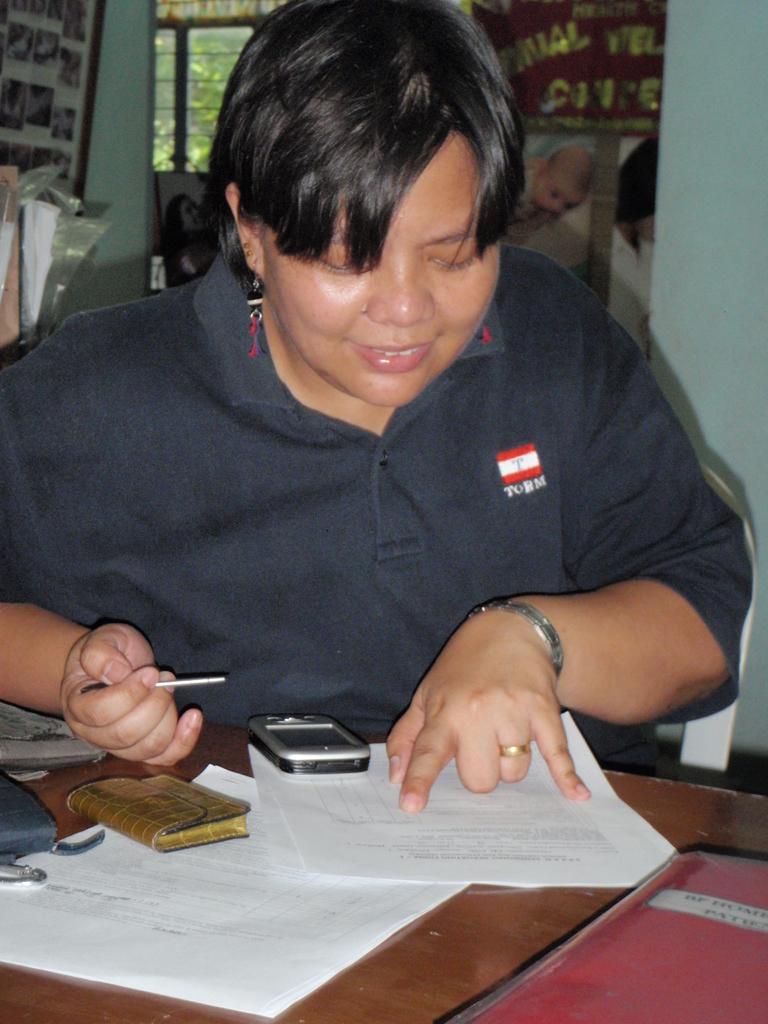Describe this image in one or two sentences. This picture is clicked inside. In the foreground there is a table on the top of which a mobile phone, papers and some other items are placed and there is a person wearing t-shirt, holding an object and sitting on the chair. In the background we can see the wall, window and some other objects. 